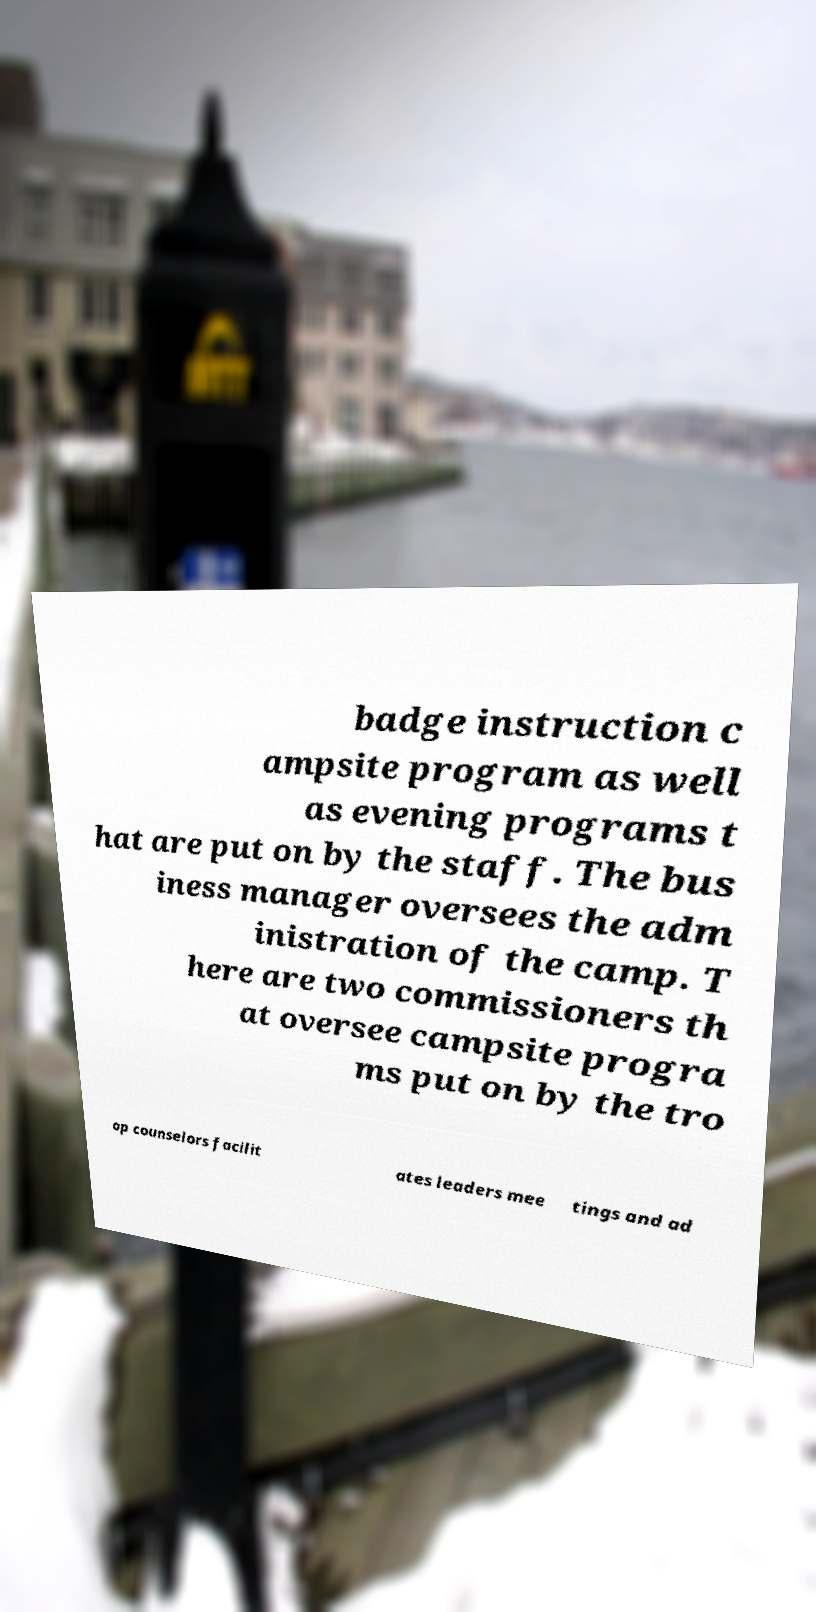Could you assist in decoding the text presented in this image and type it out clearly? badge instruction c ampsite program as well as evening programs t hat are put on by the staff. The bus iness manager oversees the adm inistration of the camp. T here are two commissioners th at oversee campsite progra ms put on by the tro op counselors facilit ates leaders mee tings and ad 